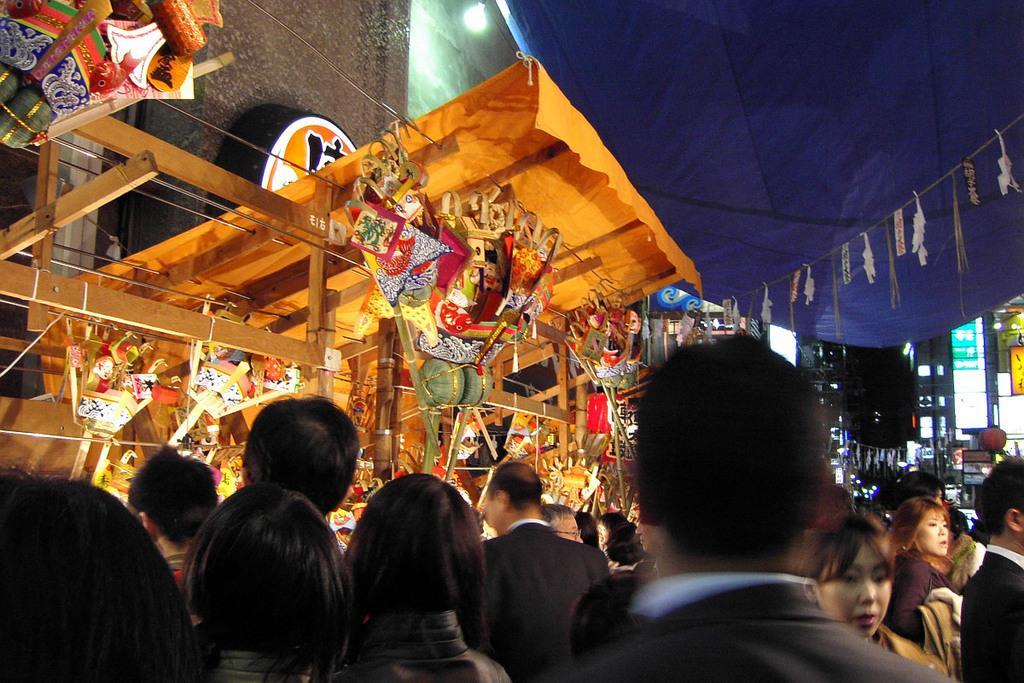In one or two sentences, can you explain what this image depicts? In this image I see few stores and I see number of people and I see the light over here. In the background I see the buildings and it is a bit dark. 